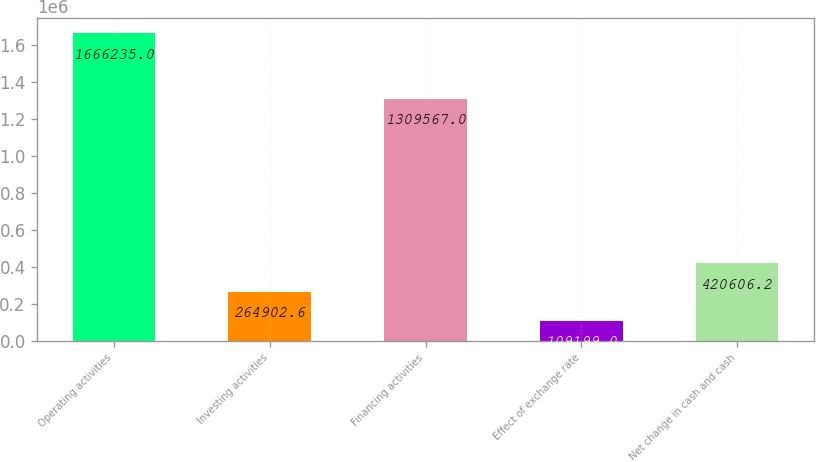Convert chart to OTSL. <chart><loc_0><loc_0><loc_500><loc_500><bar_chart><fcel>Operating activities<fcel>Investing activities<fcel>Financing activities<fcel>Effect of exchange rate<fcel>Net change in cash and cash<nl><fcel>1.66624e+06<fcel>264903<fcel>1.30957e+06<fcel>109199<fcel>420606<nl></chart> 